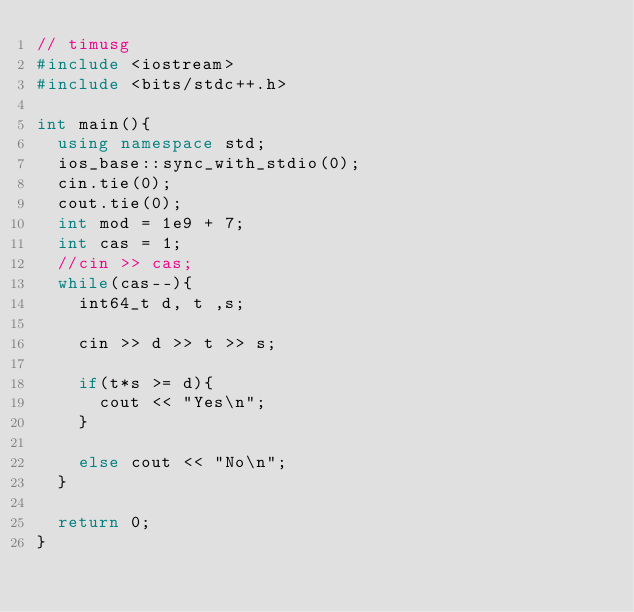<code> <loc_0><loc_0><loc_500><loc_500><_C++_>// timusg
#include <iostream>
#include <bits/stdc++.h>

int main(){
	using namespace std;
	ios_base::sync_with_stdio(0);
	cin.tie(0);
	cout.tie(0);
	int mod = 1e9 + 7;
	int cas = 1;
	//cin >> cas;
	while(cas--){
		int64_t d, t ,s;

		cin >> d >> t >> s;

		if(t*s >= d){
			cout << "Yes\n";
		}

		else cout << "No\n";
	}
	
	return 0;
}  

</code> 